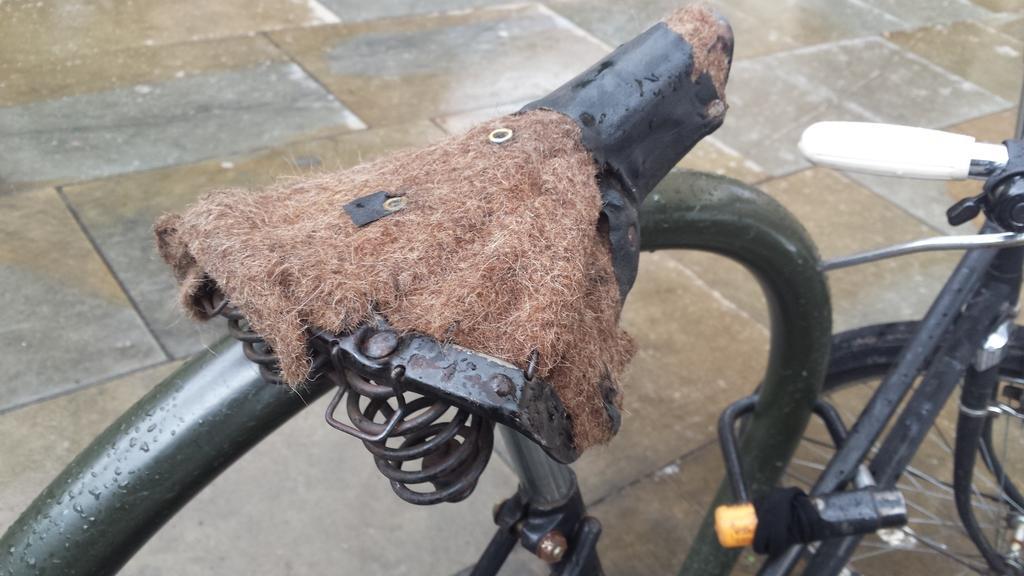Please provide a concise description of this image. In this image we can see a bicycle and its seat which is made up of coir. In the background there is floor. 